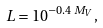Convert formula to latex. <formula><loc_0><loc_0><loc_500><loc_500>L = 1 0 ^ { - 0 . 4 \, M _ { V } } ,</formula> 